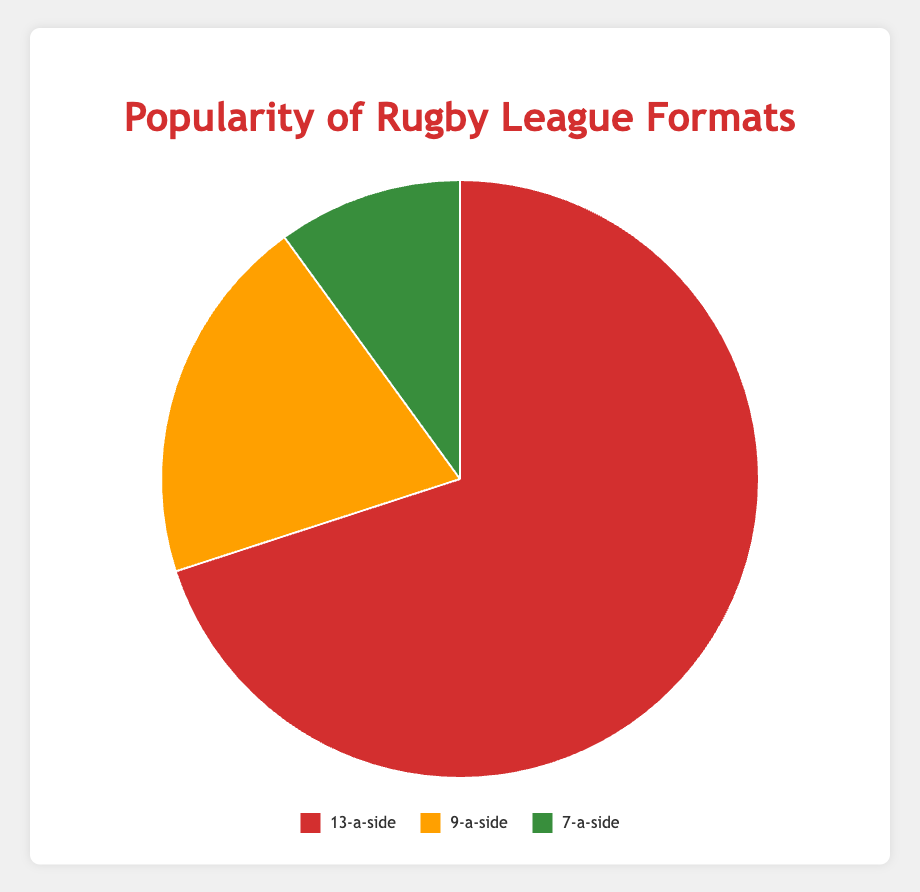What's the most popular rugby league format? The most popular rugby league format is represented by the largest slice of the pie chart, which is the red segment. The label indicates this segment represents the 13-a-side format with 70%.
Answer: 13-a-side What's the least popular rugby league format? The least popular format is represented by the smallest slice of the pie chart, which is the green segment. This segment represents the 7-a-side format with 10%.
Answer: 7-a-side Does 9-a-side rugby have more or less than half the popularity of 13-a-side rugby? To determine this, compare the percentages: 9-a-side has 20% and 13-a-side has 70%. Half of 70% is 35%. Since 20% is less than 35%, 9-a-side rugby has less than half the popularity of 13-a-side rugby.
Answer: Less What is the combined popularity of the 9-a-side and 7-a-side rugby formats? To find the combined popularity, add the percentages of 9-a-side and 7-a-side: 20% + 10% = 30%.
Answer: 30% Which format’s slice on the pie chart is yellow? By comparing the colors in the legend with the slices on the pie chart, the yellow slice corresponds to the 9-a-side format.
Answer: 9-a-side How much more popular is 13-a-side rugby compared to 7-a-side rugby? Subtract the percentage of 7-a-side from the percentage of 13-a-side: 70% - 10% = 60%.
Answer: 60% What is the average popularity percentage of all rugby league formats? Sum all the percentages and then divide by the number of formats: (70% + 20% + 10%) / 3 = 100% / 3 = 33.33%.
Answer: 33.33% If the popularity of 7-a-side rugby doubled, what would be the new percentage, and how would that affect its ranking in popularity? If the 7-a-side's popularity doubled, it would be: 10% * 2 = 20%. This would tie it with the 9-a-side format, making both equally popular, and both would be second behind the 13-a-side format.
Answer: 20% and tied with 9-a-side What fraction of the total popularity does the 9-a-side format represent? The fraction is given by its percentage divided by the total percentage (100%): 20% / 100% = 1/5 or 0.2.
Answer: 1/5 What color represents the most popular rugby league format? The most popular format (13-a-side) is represented by the largest pie slice, which is red.
Answer: Red 